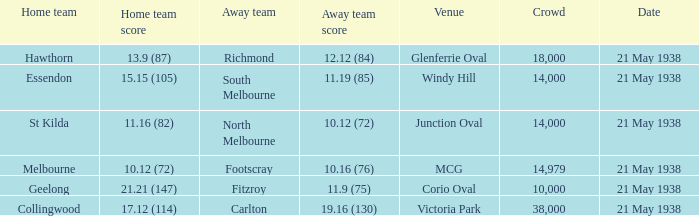Which Home team has a Venue of mcg? Melbourne. 